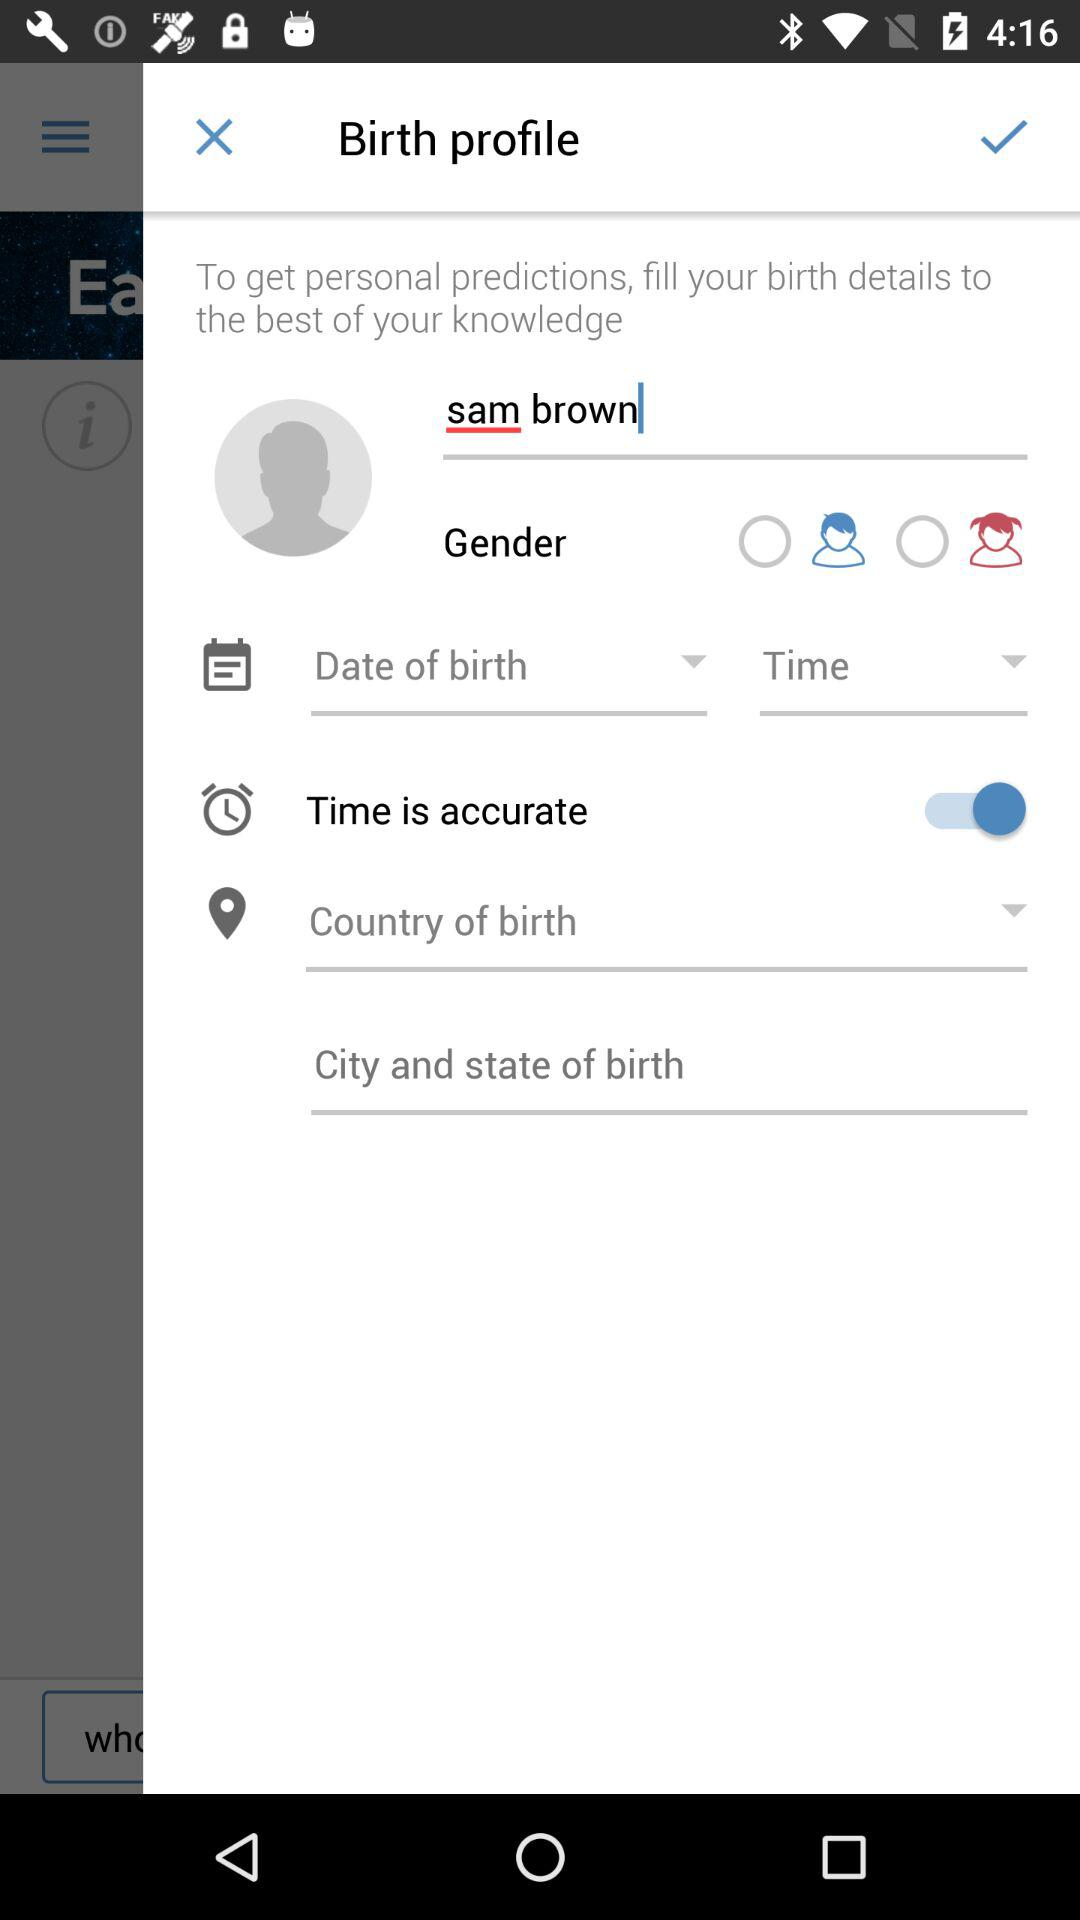What is the user name? The user name is Sam Brown. 